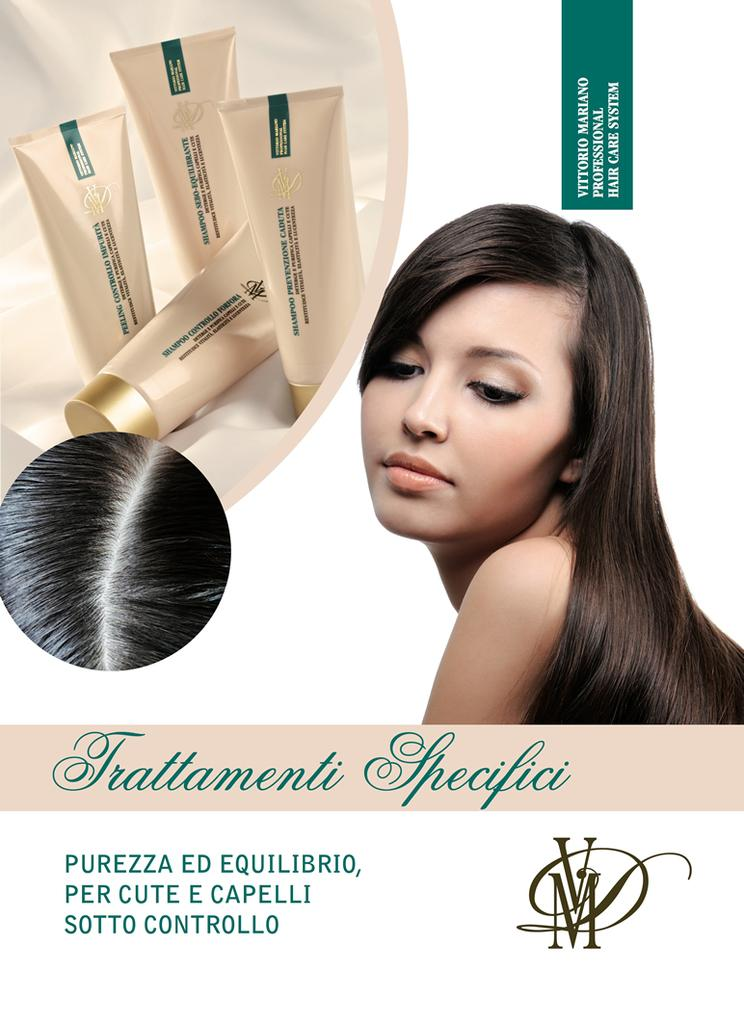Provide a one-sentence caption for the provided image. The woman is a model for the hair care brand Trattamentii. 